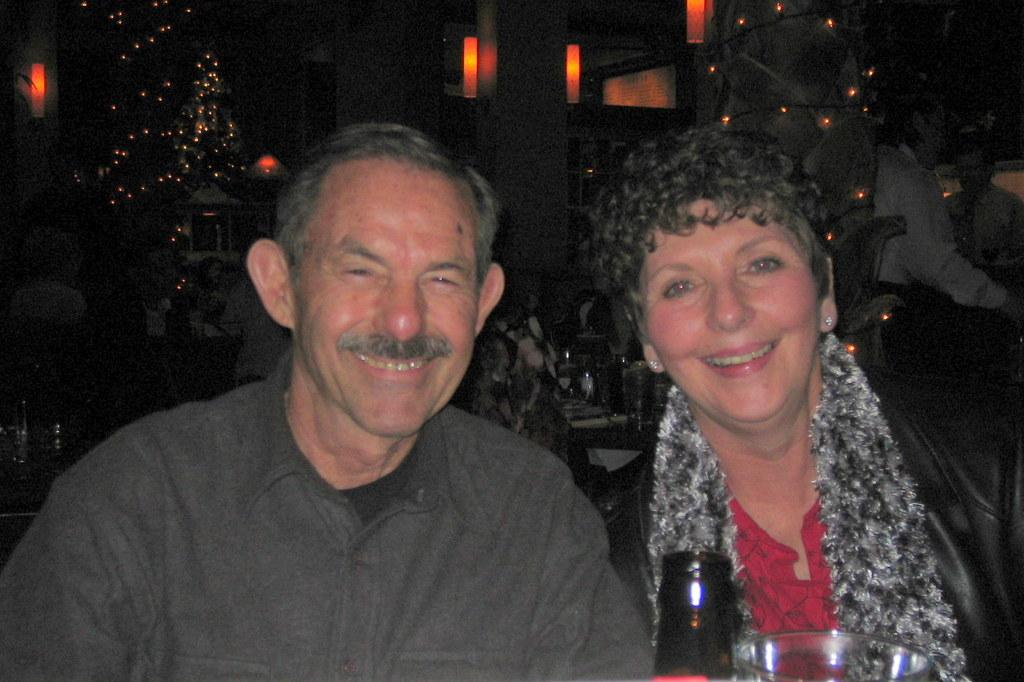How many people are in the image? There are two people in the image. What is the facial expression of the people in the image? The people are smiling. What objects are in front of the people? There is a bottle and a glass in front of the people. What can be seen in the background of the image? The background of the image is dark, and there are people and lights visible. What type of yoke is being used by the people in the image? There is no yoke present in the image. How many beads are visible on the people in the image? There are no beads visible on the people in the image. 